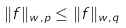Convert formula to latex. <formula><loc_0><loc_0><loc_500><loc_500>\| f \| _ { w , p } \leq \| f \| _ { w , q }</formula> 